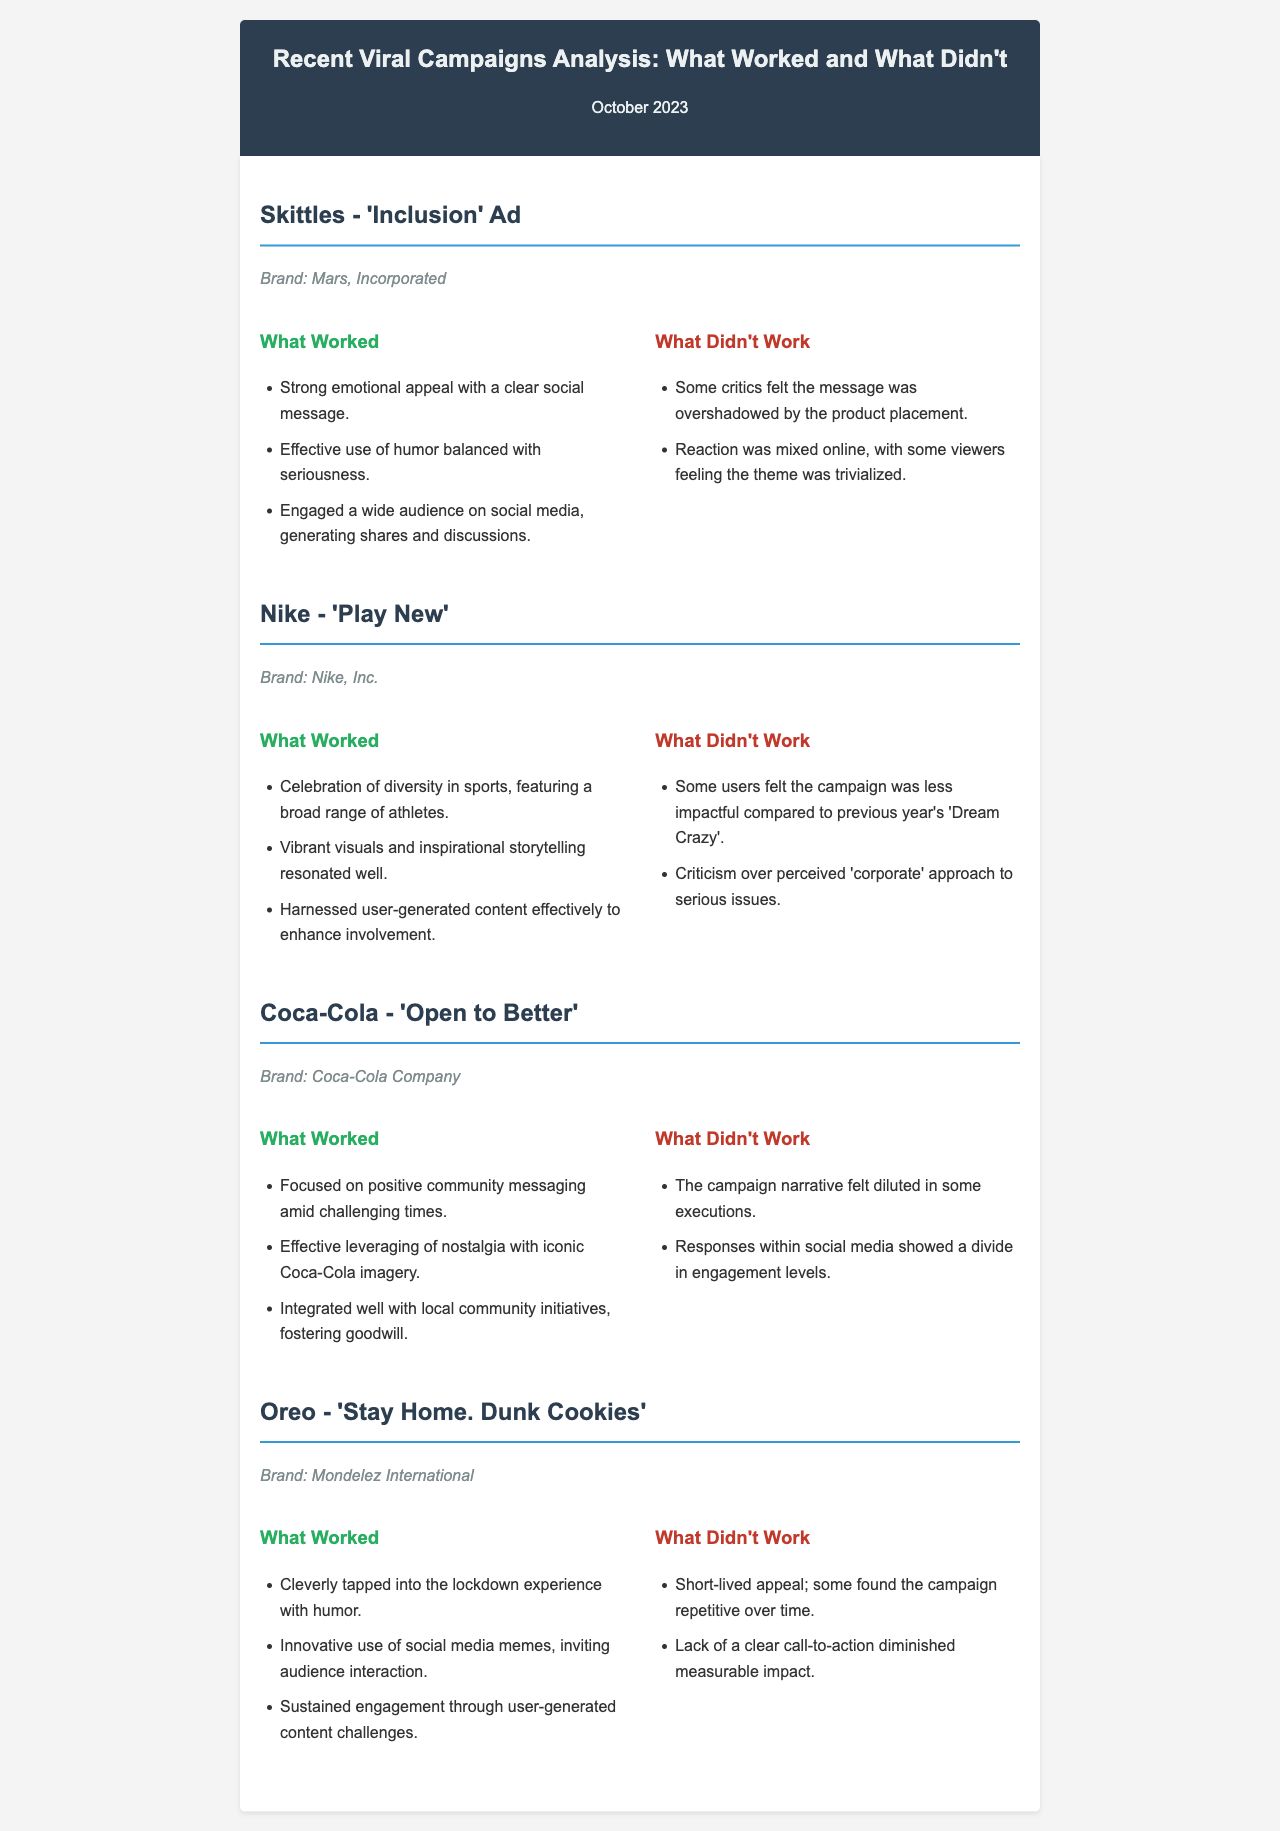what was the theme of the Skittles campaign? The theme of the Skittles campaign is 'Inclusion'.
Answer: Inclusion who is the brand behind the 'Play New' campaign? The brand behind the 'Play New' campaign is Nike, Inc.
Answer: Nike, Inc what was one effective aspect of Oreo's campaign? One effective aspect of Oreo's campaign was its innovative use of social media memes.
Answer: Innovative use of social media memes what criticism did the Coca-Cola campaign face? The Coca-Cola campaign faced criticism that the narrative felt diluted in some executions.
Answer: Diluted narrative how did Nike's campaign appeal to its audience? Nike's campaign celebrated diversity in sports, featuring a broad range of athletes.
Answer: Celebrated diversity in sports what was a common critique of the Skittles campaign? A common critique of the Skittles campaign was that the message was overshadowed by product placement.
Answer: Overshadowed by product placement which company launched the 'Open to Better' campaign? The company that launched the 'Open to Better' campaign is Coca-Cola Company.
Answer: Coca-Cola Company what was a reason for the lack of impact in Nike's campaign? A reason for the lack of impact was that some users felt it was less impactful than the previous year's 'Dream Crazy'.
Answer: Less impactful than previous year which campaign integrated well with local community initiatives? The campaign that integrated well with local community initiatives is Coca-Cola's 'Open to Better'.
Answer: Coca-Cola's 'Open to Better' 